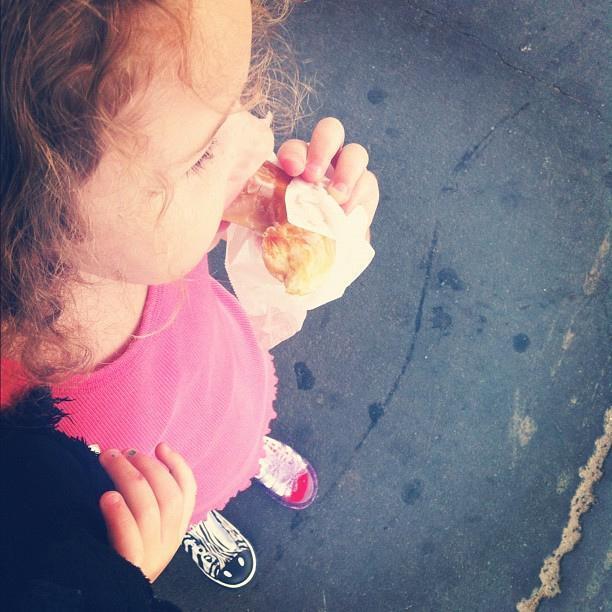What color is one of the girl's shoes?
Pick the right solution, then justify: 'Answer: answer
Rationale: rationale.'
Options: Orange, black, green, blue. Answer: black.
Rationale: The shoes are black. 